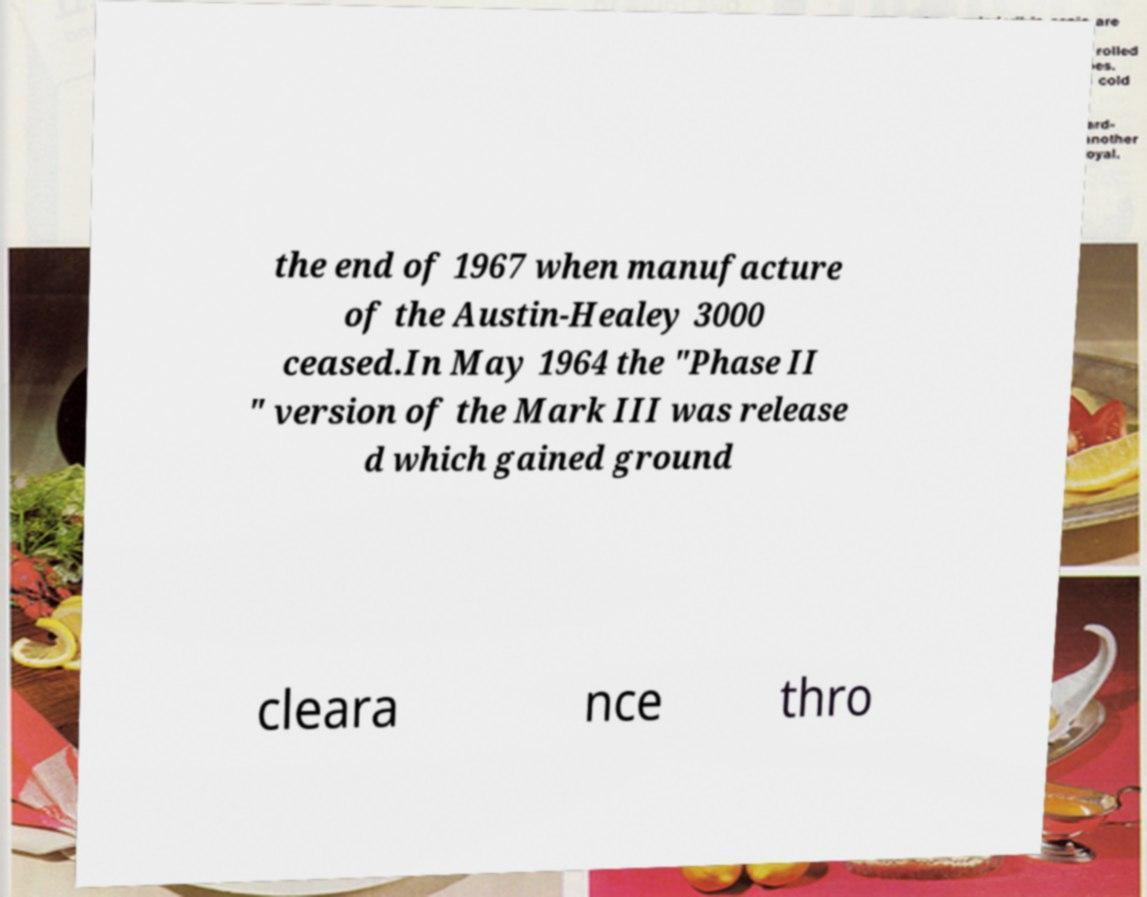I need the written content from this picture converted into text. Can you do that? the end of 1967 when manufacture of the Austin-Healey 3000 ceased.In May 1964 the "Phase II " version of the Mark III was release d which gained ground cleara nce thro 